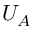<formula> <loc_0><loc_0><loc_500><loc_500>U _ { A }</formula> 